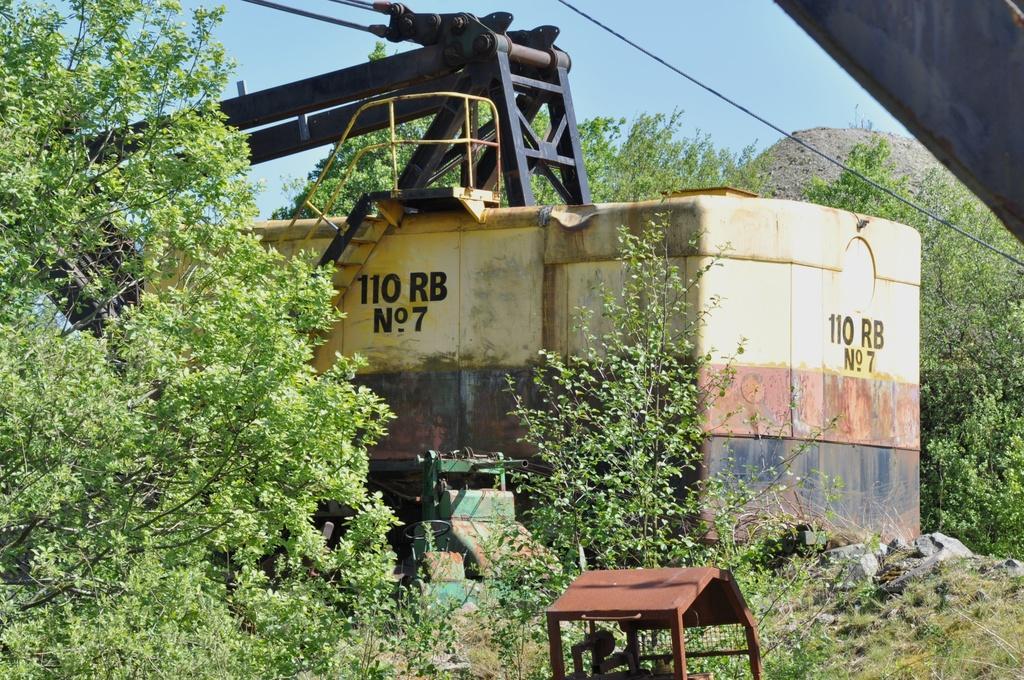Describe this image in one or two sentences. In this picture we can see a machine. There is a brown object. We can see a few trees in the background. 